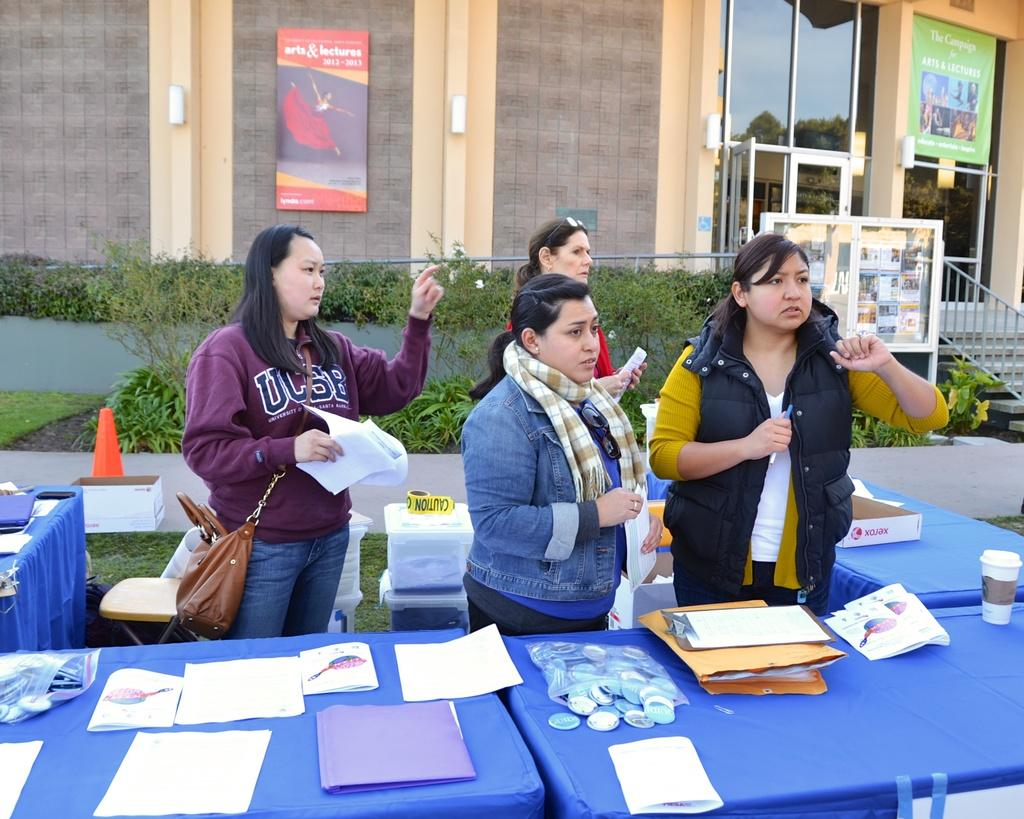What can be seen in the image? There are ladies standing in the image. What is in front of the ladies? There is a table in front of the ladies. What is on the table? There is paper, a pouch, and a cup on the table. What can be seen in the background of the image? There is a building and plants in the background of the image. How many kittens are playing with shoes made of leather in the image? There are no kittens or shoes made of leather present in the image. 